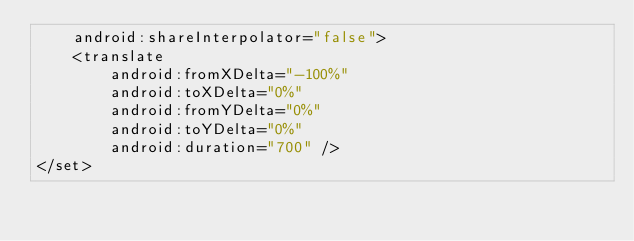<code> <loc_0><loc_0><loc_500><loc_500><_XML_>    android:shareInterpolator="false">
    <translate
        android:fromXDelta="-100%"
        android:toXDelta="0%"
        android:fromYDelta="0%"
        android:toYDelta="0%"
        android:duration="700" />
</set></code> 